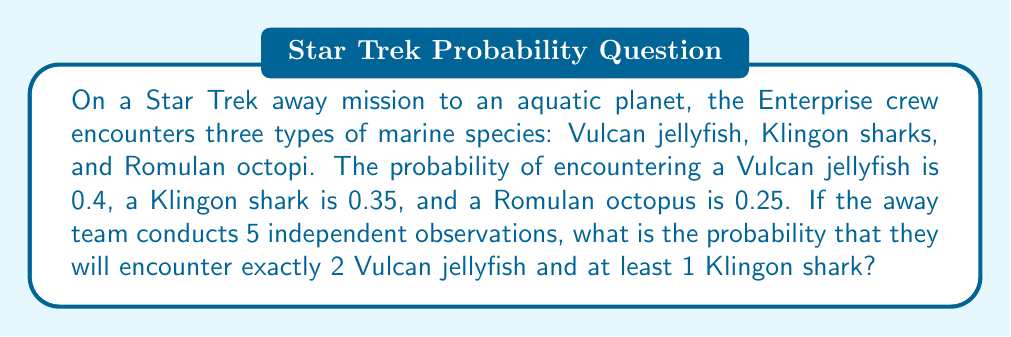Teach me how to tackle this problem. Let's approach this problem step-by-step using the concepts of probability and binomial distribution.

1) First, we need to calculate the probability of encountering exactly 2 Vulcan jellyfish in 5 observations. This follows a binomial distribution:

   $P(X = 2) = \binom{5}{2} p^2 (1-p)^{3}$
   
   Where $p = 0.4$ (probability of encountering a Vulcan jellyfish)
   
   $P(X = 2) = \binom{5}{2} (0.4)^2 (0.6)^3 = 10 \times 0.16 \times 0.216 = 0.3456$

2) Next, we need to calculate the probability of encountering at least 1 Klingon shark in the remaining 3 observations. It's easier to calculate the probability of not encountering any Klingon sharks and subtract from 1:

   $P(\text{at least 1 Klingon shark}) = 1 - P(\text{no Klingon sharks})$
   $= 1 - (1-0.35)^3 = 1 - (0.65)^3 = 1 - 0.274625 = 0.725375$

3) Since these events are independent, we multiply the probabilities:

   $P(\text{2 Vulcan jellyfish AND at least 1 Klingon shark}) = 0.3456 \times 0.725375 = 0.2506656$

Therefore, the probability of encountering exactly 2 Vulcan jellyfish and at least 1 Klingon shark in 5 observations is approximately 0.2507 or 25.07%.
Answer: $0.2507$ or $25.07\%$ 